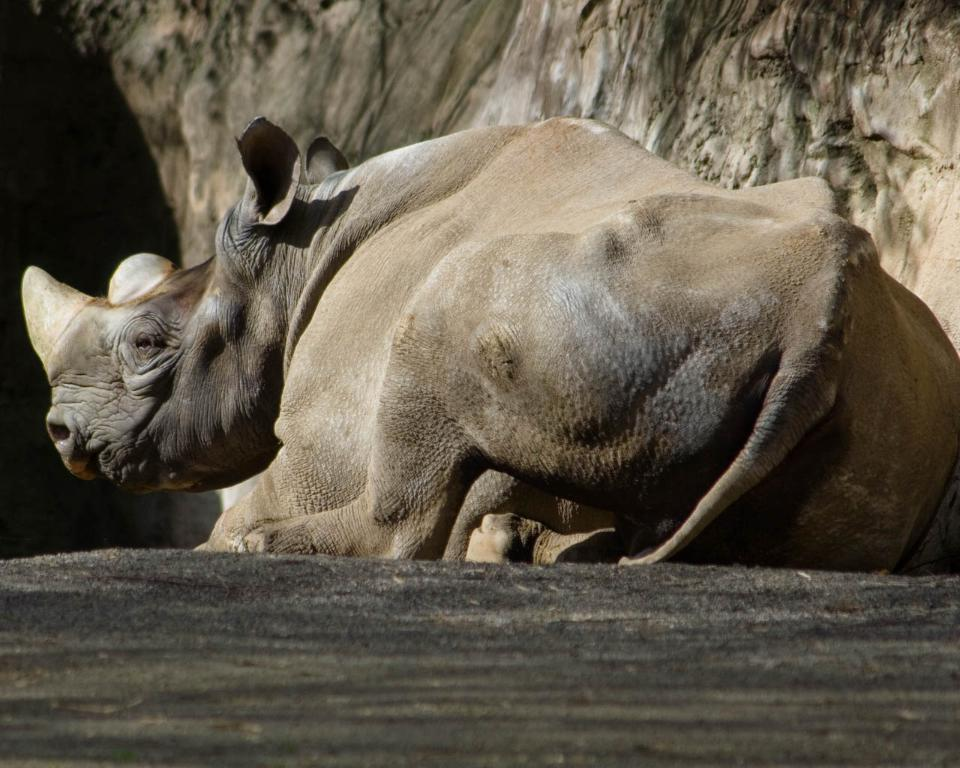What animal is the main subject of the image? There is a rhinoceros in the image. What is the rhinoceros doing in the image? The rhinoceros is sitting on the ground. What can be seen in the background of the image? There is a hill in the background of the image. How many plates are stacked on the rhinoceros's back in the image? There are no plates present in the image; it features a rhinoceros sitting on the ground with a hill in the background. 